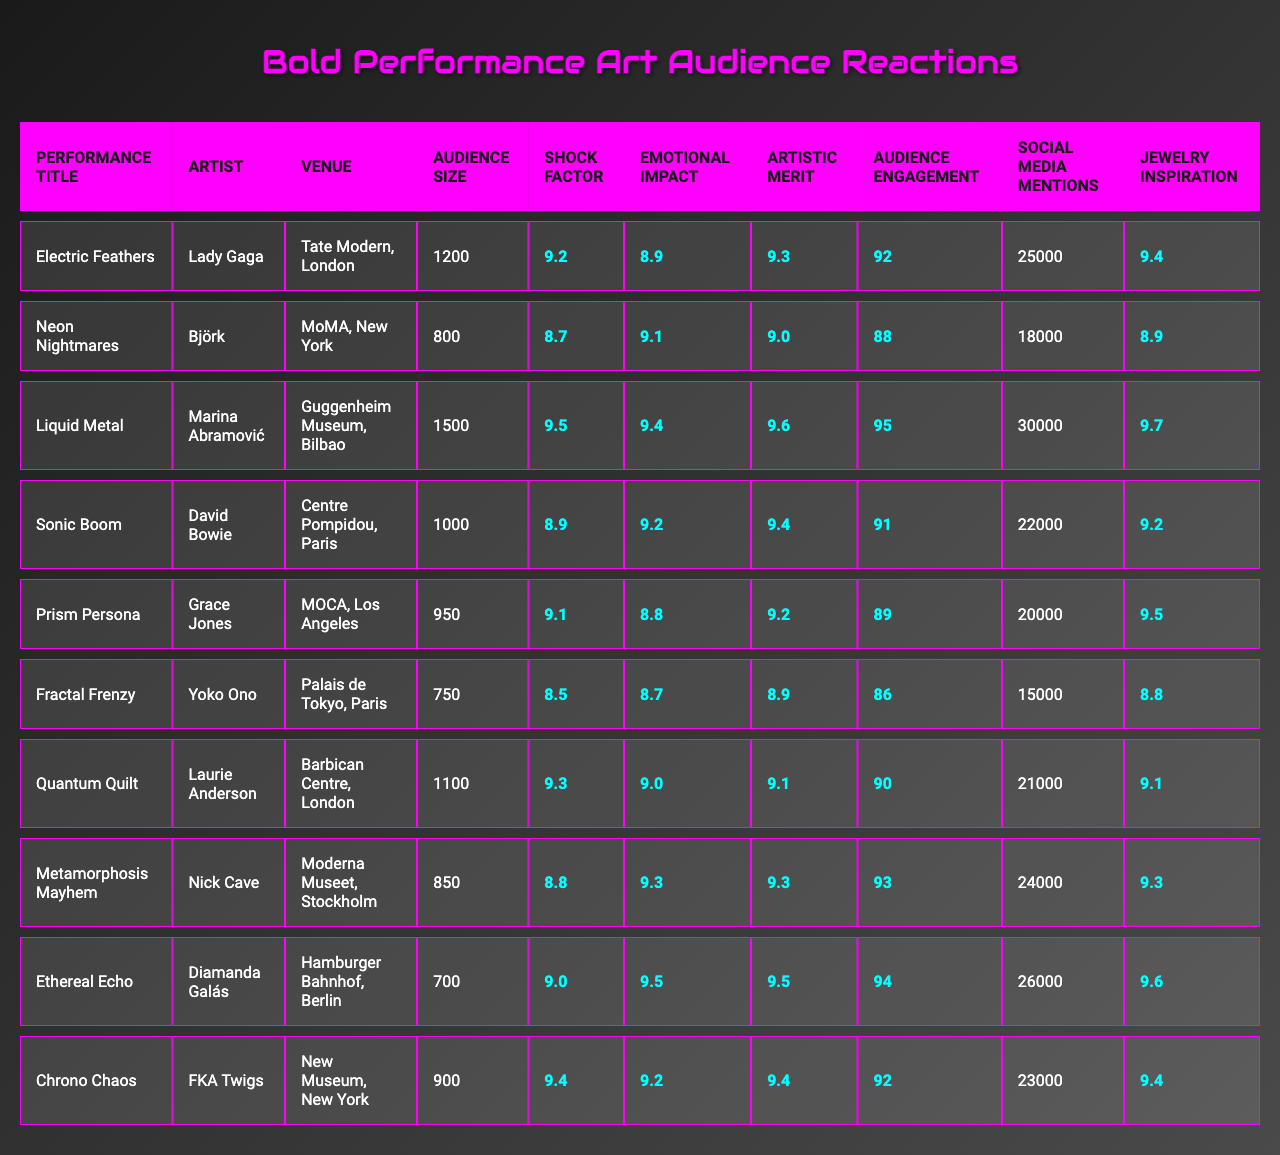What is the performance title with the highest shock factor rating? The table shows "Liquid Metal" has a shock factor rating of 9.5, which is the highest among all performances listed.
Answer: Liquid Metal Which artist has the lowest emotional impact rating? Examining the table, "Yoko Ono" has the lowest emotional impact rating of 8.7.
Answer: Yoko Ono What is the audience size for "Ethereal Echo"? The table indicates that the audience size for "Ethereal Echo" is 700.
Answer: 700 What is the average artistic merit rating across all performances? To calculate the average, sum all artistic merit ratings: (9.3 + 9.0 + 9.6 + 9.4 + 9.2 + 8.9 + 9.1 + 9.3 + 9.5 + 9.4) = 92.3. Then divide by the number of performances (10): 92.3 / 10 = 9.23.
Answer: 9.23 Which performance has the highest number of social media mentions? The highest number of social media mentions is for "Liquid Metal," with 30,000 mentions.
Answer: Liquid Metal Did "Grace Jones" have a higher jewelry inspiration rating than her emotional impact rating? "Grace Jones" has a jewelry inspiration rating of 9.5 and an emotional impact rating of 8.8, which means her jewelry inspiration rating is indeed higher.
Answer: Yes What is the difference in audience engagement scores between "Quantum Quilt" and "Neon Nightmares"? The audience engagement score for "Quantum Quilt" is 90 and for "Neon Nightmares" is 88. The difference is 90 - 88 = 2.
Answer: 2 Who performed at the venue with the largest audience size? "Marina Abramović" performed at the Guggenheim Museum in Bilbao, which has the largest audience size of 1500.
Answer: Marina Abramović Which performance had both a high shock factor and emotional impact rating? "Liquid Metal" has a shock factor rating of 9.5 and an emotional impact rating of 9.4, indicating both are high.
Answer: Liquid Metal What is the average audience size for performances held in Paris? From the table, the performances in Paris are "Sonic Boom" and "Fractal Frenzy," with audience sizes of 1000 and 750, respectively. The average is (1000 + 750) / 2 = 875.
Answer: 875 